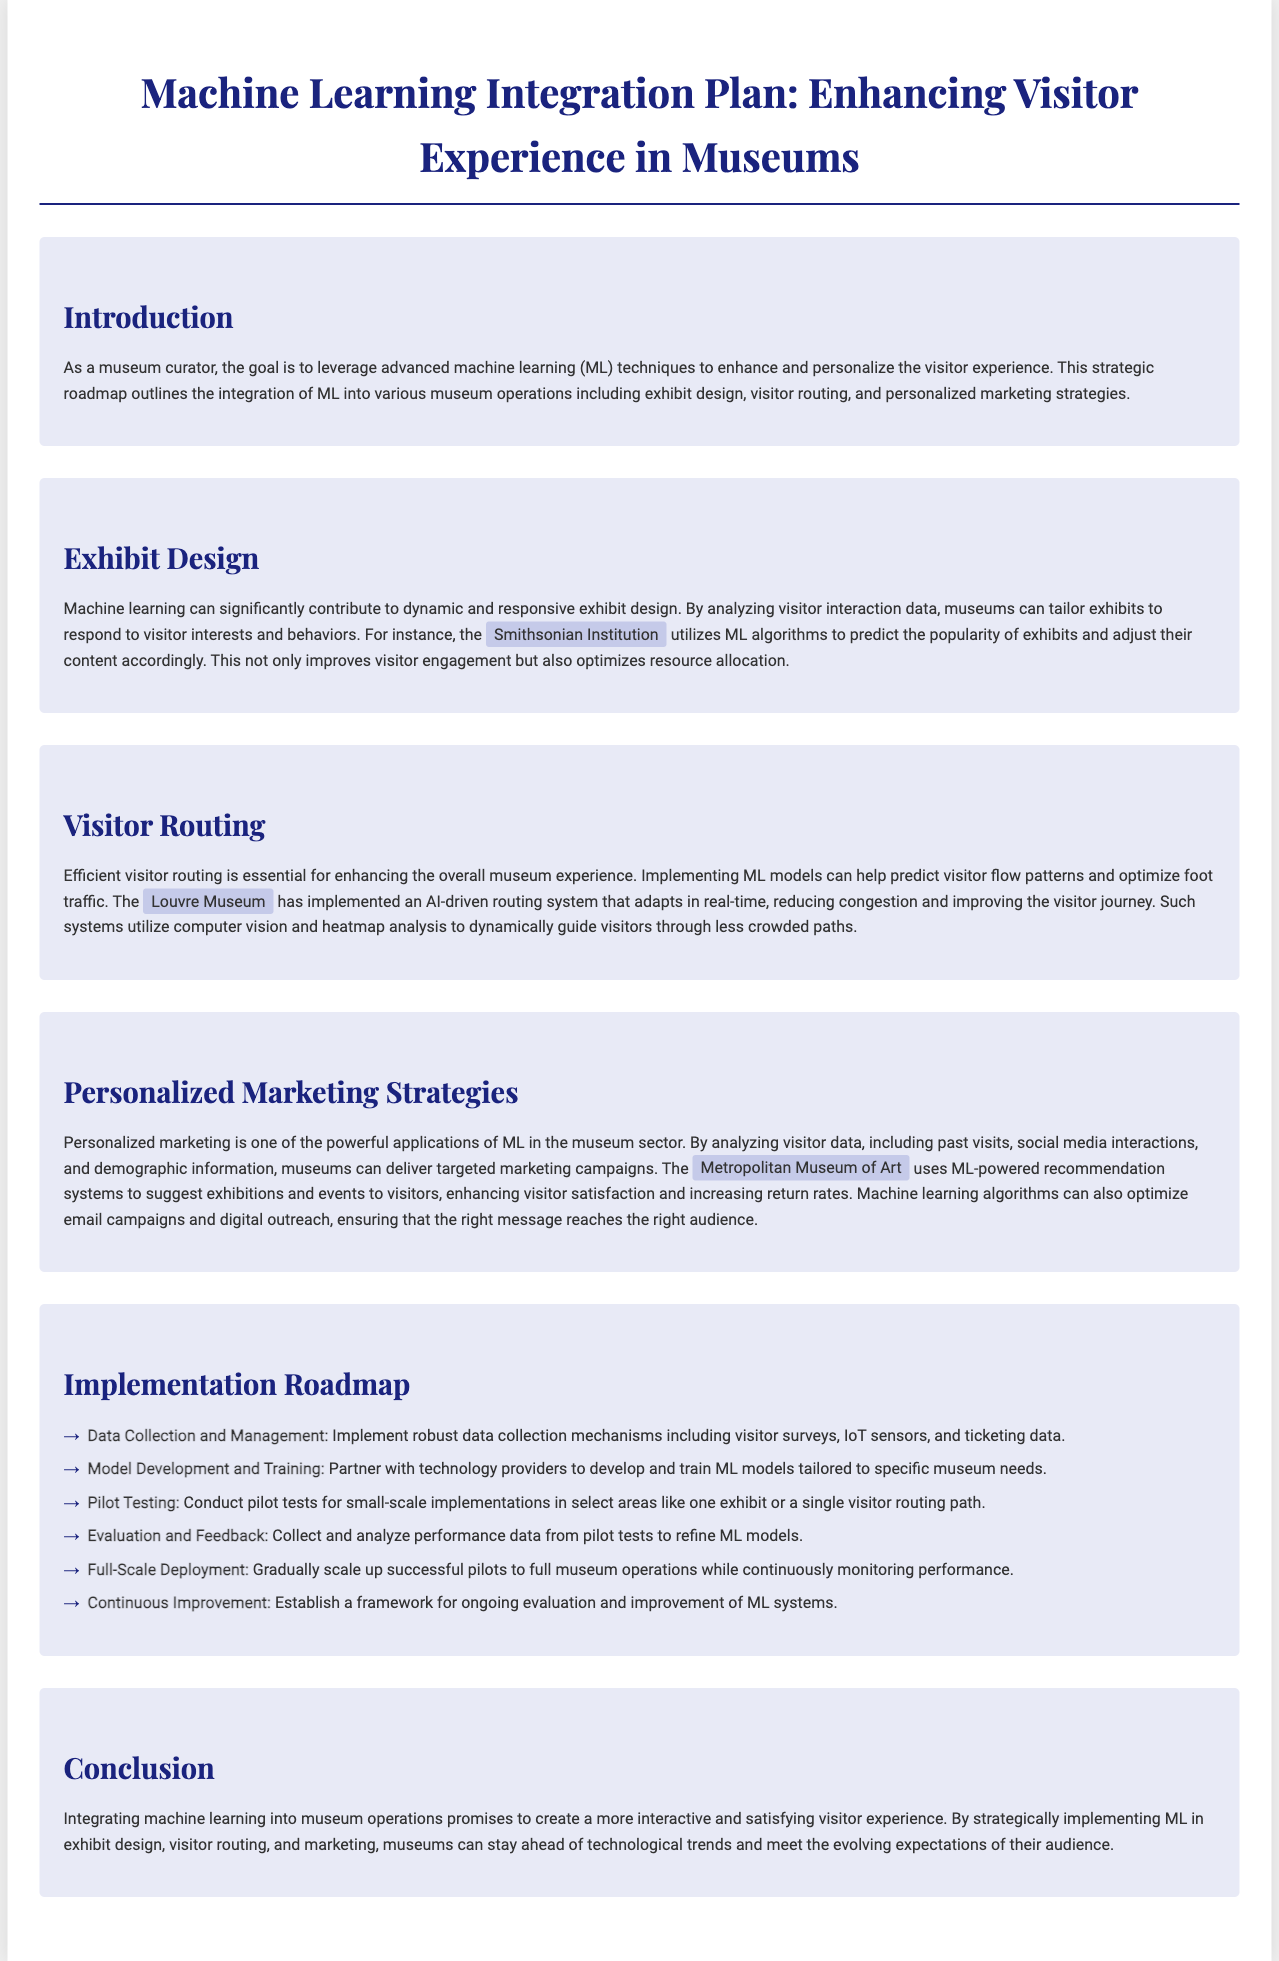what is the main goal of the integration plan? The main goal is to leverage advanced machine learning techniques to enhance and personalize the visitor experience.
Answer: enhance and personalize the visitor experience which museum utilizes ML algorithms to predict the popularity of exhibits? The Smithsonian Institution is mentioned as utilizing ML algorithms to predict exhibit popularity.
Answer: Smithsonian Institution what is one key application of machine learning in marketing? One key application is delivering targeted marketing campaigns.
Answer: delivering targeted marketing campaigns how does the Louvre Museum improve visitor routing? The Louvre Museum has implemented an AI-driven routing system that adapts in real-time.
Answer: AI-driven routing system what is the first step in the implementation roadmap? The first step is Data Collection and Management.
Answer: Data Collection and Management which museum uses ML-powered recommendation systems? The Metropolitan Museum of Art uses ML-powered recommendation systems.
Answer: Metropolitan Museum of Art what is the purpose of pilot testing in the implementation roadmap? Pilot testing is conducted for small-scale implementations in select areas.
Answer: small-scale implementations in select areas how many implementation steps are outlined in the document? There are six implementation steps outlined in the document.
Answer: six 